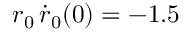Convert formula to latex. <formula><loc_0><loc_0><loc_500><loc_500>r _ { 0 } \, \dot { r } _ { 0 } ( 0 ) = - 1 . 5</formula> 